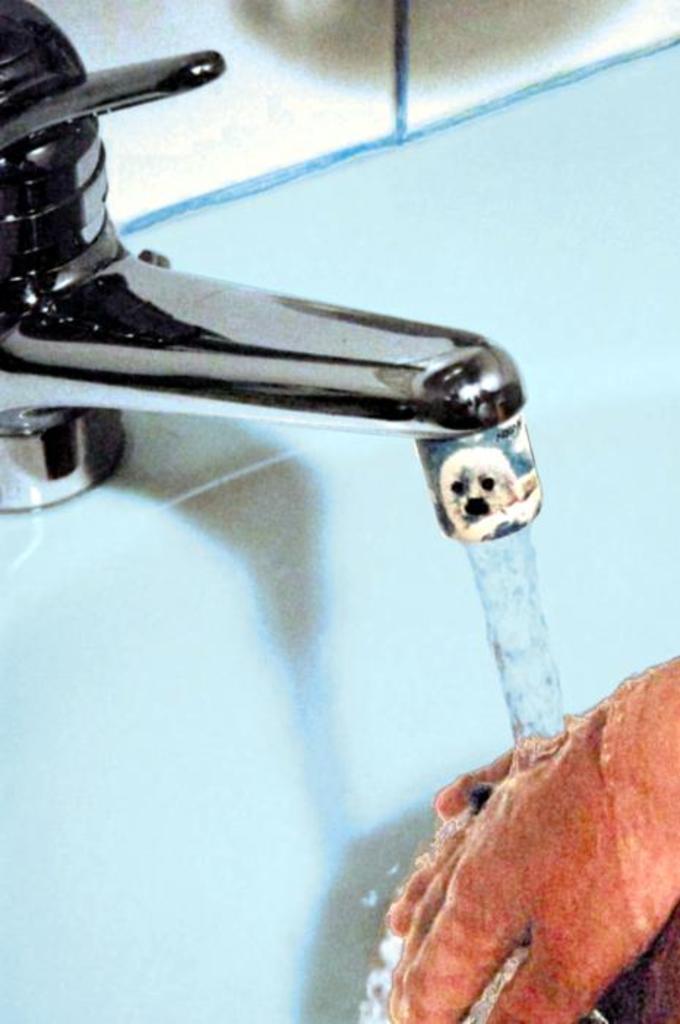In one or two sentences, can you explain what this image depicts? In this picture, we see the person washing the hands under the tap. In this picture, we see the wash basin and a tap. In the background, it might be a mirror or a white wall. 